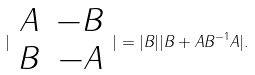<formula> <loc_0><loc_0><loc_500><loc_500>| \begin{array} { c c } A & - B \\ B & - A \end{array} | = | B | | B + A B ^ { - 1 } A | .</formula> 